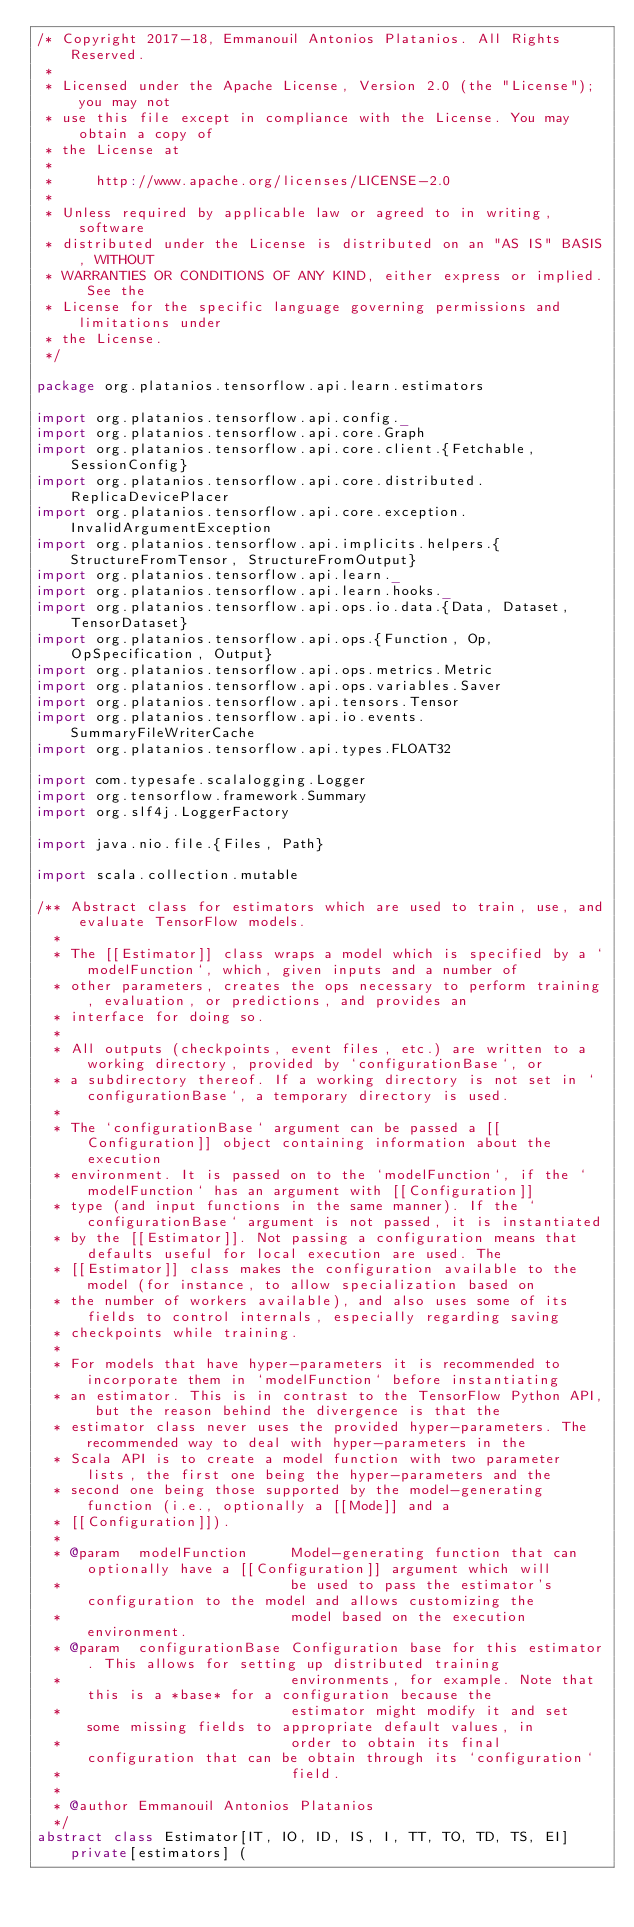<code> <loc_0><loc_0><loc_500><loc_500><_Scala_>/* Copyright 2017-18, Emmanouil Antonios Platanios. All Rights Reserved.
 *
 * Licensed under the Apache License, Version 2.0 (the "License"); you may not
 * use this file except in compliance with the License. You may obtain a copy of
 * the License at
 *
 *     http://www.apache.org/licenses/LICENSE-2.0
 *
 * Unless required by applicable law or agreed to in writing, software
 * distributed under the License is distributed on an "AS IS" BASIS, WITHOUT
 * WARRANTIES OR CONDITIONS OF ANY KIND, either express or implied. See the
 * License for the specific language governing permissions and limitations under
 * the License.
 */

package org.platanios.tensorflow.api.learn.estimators

import org.platanios.tensorflow.api.config._
import org.platanios.tensorflow.api.core.Graph
import org.platanios.tensorflow.api.core.client.{Fetchable, SessionConfig}
import org.platanios.tensorflow.api.core.distributed.ReplicaDevicePlacer
import org.platanios.tensorflow.api.core.exception.InvalidArgumentException
import org.platanios.tensorflow.api.implicits.helpers.{StructureFromTensor, StructureFromOutput}
import org.platanios.tensorflow.api.learn._
import org.platanios.tensorflow.api.learn.hooks._
import org.platanios.tensorflow.api.ops.io.data.{Data, Dataset, TensorDataset}
import org.platanios.tensorflow.api.ops.{Function, Op, OpSpecification, Output}
import org.platanios.tensorflow.api.ops.metrics.Metric
import org.platanios.tensorflow.api.ops.variables.Saver
import org.platanios.tensorflow.api.tensors.Tensor
import org.platanios.tensorflow.api.io.events.SummaryFileWriterCache
import org.platanios.tensorflow.api.types.FLOAT32

import com.typesafe.scalalogging.Logger
import org.tensorflow.framework.Summary
import org.slf4j.LoggerFactory

import java.nio.file.{Files, Path}

import scala.collection.mutable

/** Abstract class for estimators which are used to train, use, and evaluate TensorFlow models.
  *
  * The [[Estimator]] class wraps a model which is specified by a `modelFunction`, which, given inputs and a number of
  * other parameters, creates the ops necessary to perform training, evaluation, or predictions, and provides an
  * interface for doing so.
  *
  * All outputs (checkpoints, event files, etc.) are written to a working directory, provided by `configurationBase`, or
  * a subdirectory thereof. If a working directory is not set in `configurationBase`, a temporary directory is used.
  *
  * The `configurationBase` argument can be passed a [[Configuration]] object containing information about the execution
  * environment. It is passed on to the `modelFunction`, if the `modelFunction` has an argument with [[Configuration]]
  * type (and input functions in the same manner). If the `configurationBase` argument is not passed, it is instantiated
  * by the [[Estimator]]. Not passing a configuration means that defaults useful for local execution are used. The
  * [[Estimator]] class makes the configuration available to the model (for instance, to allow specialization based on
  * the number of workers available), and also uses some of its fields to control internals, especially regarding saving
  * checkpoints while training.
  *
  * For models that have hyper-parameters it is recommended to incorporate them in `modelFunction` before instantiating
  * an estimator. This is in contrast to the TensorFlow Python API, but the reason behind the divergence is that the
  * estimator class never uses the provided hyper-parameters. The recommended way to deal with hyper-parameters in the
  * Scala API is to create a model function with two parameter lists, the first one being the hyper-parameters and the
  * second one being those supported by the model-generating function (i.e., optionally a [[Mode]] and a
  * [[Configuration]]).
  *
  * @param  modelFunction     Model-generating function that can optionally have a [[Configuration]] argument which will
  *                           be used to pass the estimator's configuration to the model and allows customizing the
  *                           model based on the execution environment.
  * @param  configurationBase Configuration base for this estimator. This allows for setting up distributed training
  *                           environments, for example. Note that this is a *base* for a configuration because the
  *                           estimator might modify it and set some missing fields to appropriate default values, in
  *                           order to obtain its final configuration that can be obtain through its `configuration`
  *                           field.
  *
  * @author Emmanouil Antonios Platanios
  */
abstract class Estimator[IT, IO, ID, IS, I, TT, TO, TD, TS, EI] private[estimators] (</code> 